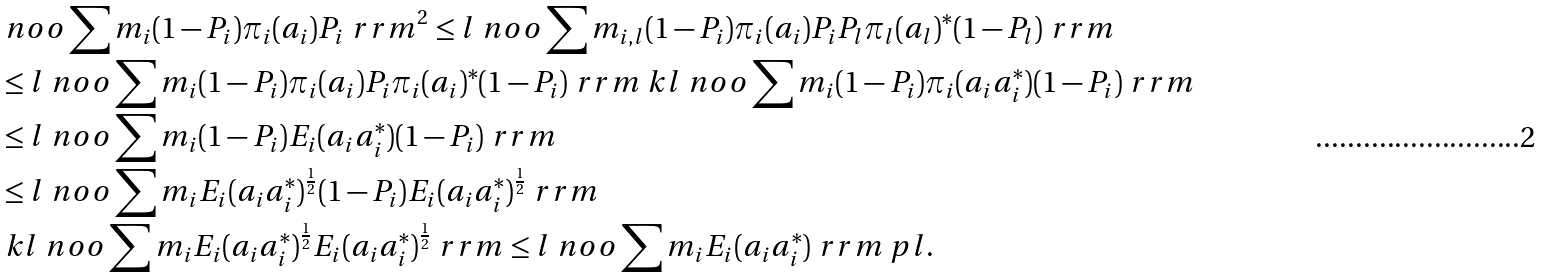<formula> <loc_0><loc_0><loc_500><loc_500>& \ n o o \sum m _ { i } ( 1 - P _ { i } ) \pi _ { i } ( a _ { i } ) P _ { i } \ r r m ^ { 2 } \leq l \ n o o \sum m _ { i , l } ( 1 - P _ { i } ) \pi _ { i } ( a _ { i } ) P _ { i } P _ { l } \pi _ { l } ( a _ { l } ) ^ { * } ( 1 - P _ { l } ) \ r r m \\ & \leq l \ n o o \sum m _ { i } ( 1 - P _ { i } ) \pi _ { i } ( a _ { i } ) P _ { i } \pi _ { i } ( a _ { i } ) ^ { * } ( 1 - P _ { i } ) \ r r m \ k l \ n o o \sum m _ { i } ( 1 - P _ { i } ) \pi _ { i } ( a _ { i } a _ { i } ^ { * } ) ( 1 - P _ { i } ) \ r r m \\ & \leq l \ n o o \sum m _ { i } ( 1 - P _ { i } ) E _ { i } ( a _ { i } a _ { i } ^ { * } ) ( 1 - P _ { i } ) \ r r m \\ & \leq l \ n o o \sum m _ { i } E _ { i } ( a _ { i } a _ { i } ^ { * } ) ^ { \frac { 1 } { 2 } } ( 1 - P _ { i } ) E _ { i } ( a _ { i } a _ { i } ^ { * } ) ^ { \frac { 1 } { 2 } } \ r r m \\ & \ k l \ n o o \sum m _ { i } E _ { i } ( a _ { i } a _ { i } ^ { * } ) ^ { \frac { 1 } { 2 } } E _ { i } ( a _ { i } a _ { i } ^ { * } ) ^ { \frac { 1 } { 2 } } \ r r m \leq l \ n o o \sum m _ { i } E _ { i } ( a _ { i } a _ { i } ^ { * } ) \ r r m \ p l .</formula> 